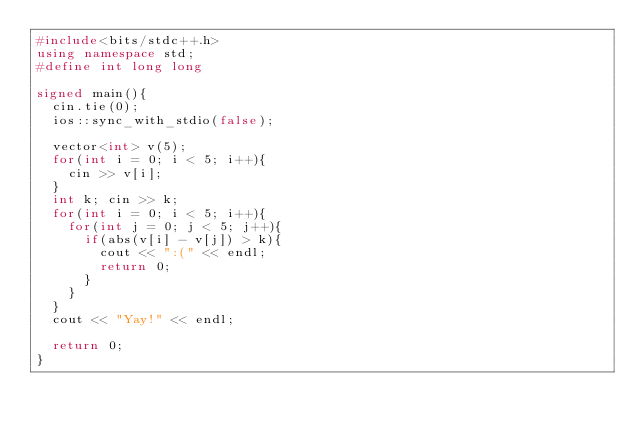Convert code to text. <code><loc_0><loc_0><loc_500><loc_500><_C++_>#include<bits/stdc++.h>
using namespace std;
#define int long long

signed main(){
  cin.tie(0);
  ios::sync_with_stdio(false);

  vector<int> v(5);
  for(int i = 0; i < 5; i++){
    cin >> v[i];
  }
  int k; cin >> k;
  for(int i = 0; i < 5; i++){
    for(int j = 0; j < 5; j++){
      if(abs(v[i] - v[j]) > k){
        cout << ":(" << endl;
        return 0;
      }
    }
  }
  cout << "Yay!" << endl;

  return 0;
}
</code> 